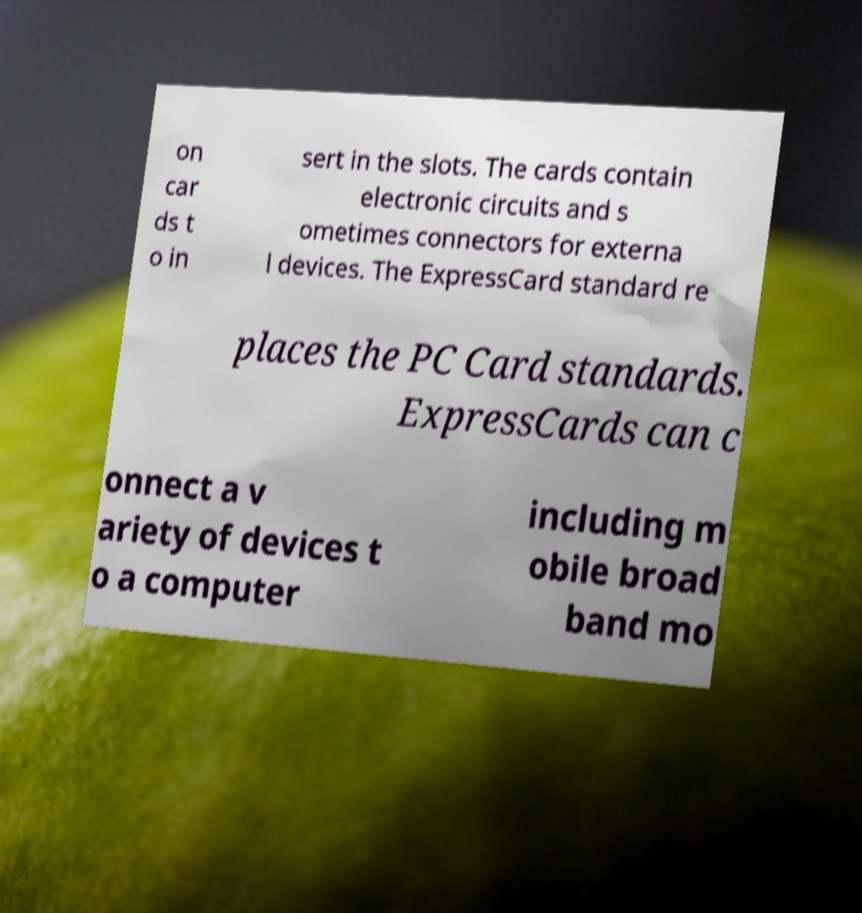Please identify and transcribe the text found in this image. on car ds t o in sert in the slots. The cards contain electronic circuits and s ometimes connectors for externa l devices. The ExpressCard standard re places the PC Card standards. ExpressCards can c onnect a v ariety of devices t o a computer including m obile broad band mo 